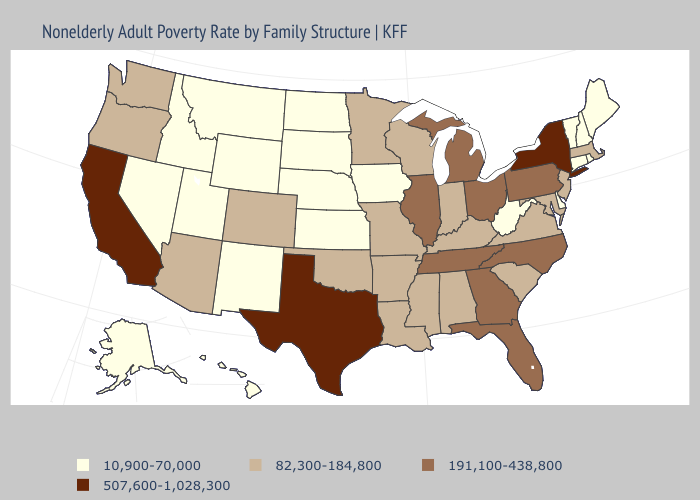Does South Dakota have the same value as Hawaii?
Answer briefly. Yes. Does Michigan have a lower value than Virginia?
Quick response, please. No. Among the states that border Vermont , does Massachusetts have the lowest value?
Keep it brief. No. How many symbols are there in the legend?
Be succinct. 4. How many symbols are there in the legend?
Answer briefly. 4. Name the states that have a value in the range 507,600-1,028,300?
Write a very short answer. California, New York, Texas. What is the lowest value in the Northeast?
Keep it brief. 10,900-70,000. Name the states that have a value in the range 191,100-438,800?
Keep it brief. Florida, Georgia, Illinois, Michigan, North Carolina, Ohio, Pennsylvania, Tennessee. Does New York have the highest value in the Northeast?
Concise answer only. Yes. Among the states that border Idaho , does Oregon have the lowest value?
Be succinct. No. Does Vermont have the highest value in the Northeast?
Be succinct. No. Name the states that have a value in the range 191,100-438,800?
Quick response, please. Florida, Georgia, Illinois, Michigan, North Carolina, Ohio, Pennsylvania, Tennessee. Which states have the lowest value in the South?
Write a very short answer. Delaware, West Virginia. Among the states that border North Dakota , does Minnesota have the highest value?
Be succinct. Yes. Does Ohio have the highest value in the MidWest?
Keep it brief. Yes. 